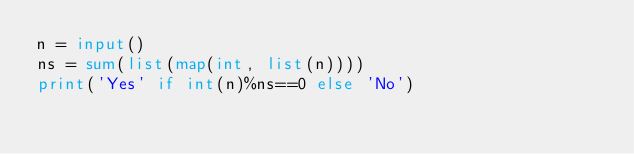Convert code to text. <code><loc_0><loc_0><loc_500><loc_500><_Python_>n = input()
ns = sum(list(map(int, list(n))))
print('Yes' if int(n)%ns==0 else 'No')
</code> 